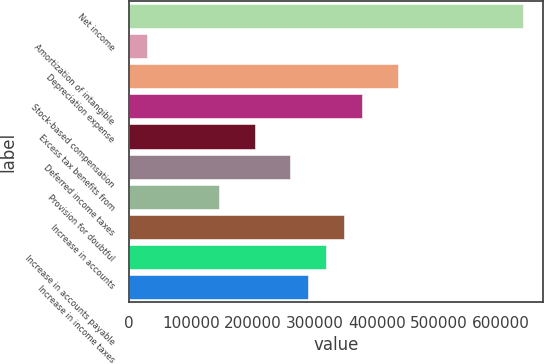<chart> <loc_0><loc_0><loc_500><loc_500><bar_chart><fcel>Net income<fcel>Amortization of intangible<fcel>Depreciation expense<fcel>Stock-based compensation<fcel>Excess tax benefits from<fcel>Deferred income taxes<fcel>Provision for doubtful<fcel>Increase in accounts<fcel>Increase in accounts payable<fcel>Increase in income taxes<nl><fcel>636061<fcel>29014<fcel>433712<fcel>375898<fcel>202456<fcel>260270<fcel>144642<fcel>346991<fcel>318084<fcel>289177<nl></chart> 